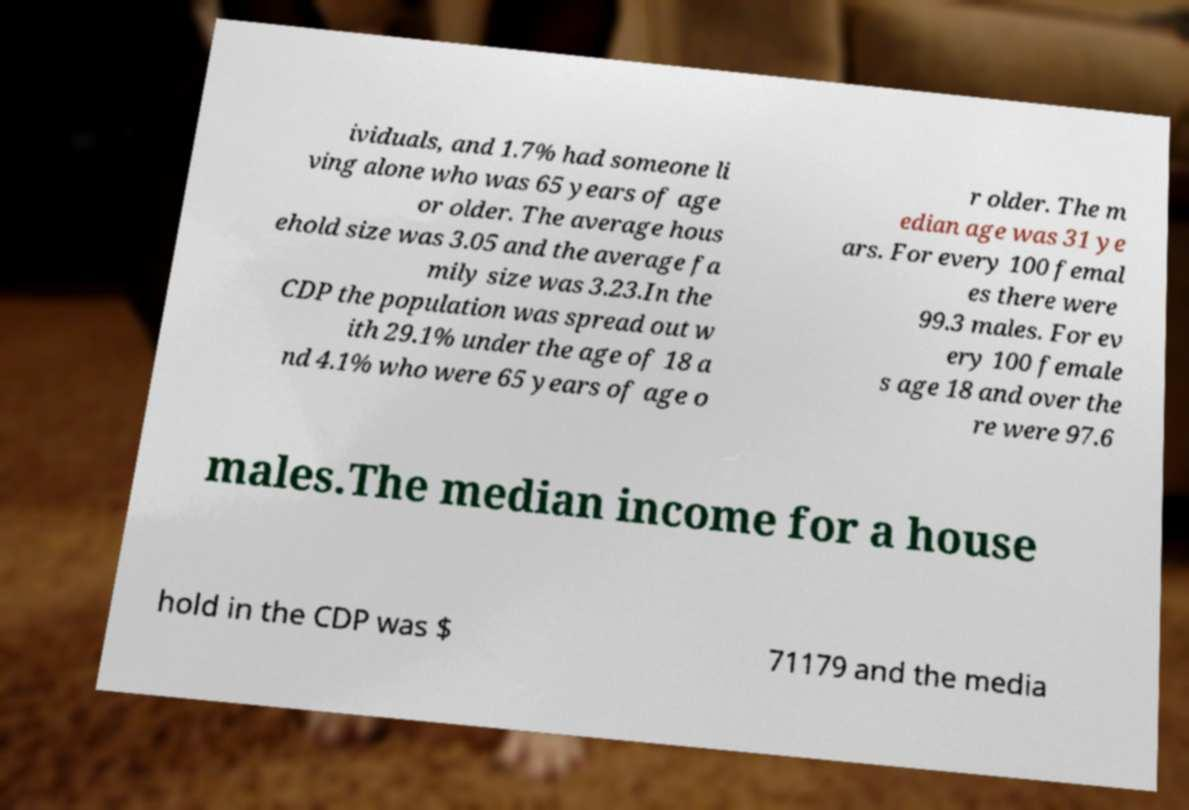I need the written content from this picture converted into text. Can you do that? ividuals, and 1.7% had someone li ving alone who was 65 years of age or older. The average hous ehold size was 3.05 and the average fa mily size was 3.23.In the CDP the population was spread out w ith 29.1% under the age of 18 a nd 4.1% who were 65 years of age o r older. The m edian age was 31 ye ars. For every 100 femal es there were 99.3 males. For ev ery 100 female s age 18 and over the re were 97.6 males.The median income for a house hold in the CDP was $ 71179 and the media 